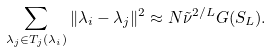Convert formula to latex. <formula><loc_0><loc_0><loc_500><loc_500>\sum _ { \lambda _ { j } \in T _ { j } ( \lambda _ { i } ) } \| \lambda _ { i } - \lambda _ { j } \| ^ { 2 } \approx N \tilde { \nu } ^ { 2 / L } G ( S _ { L } ) .</formula> 